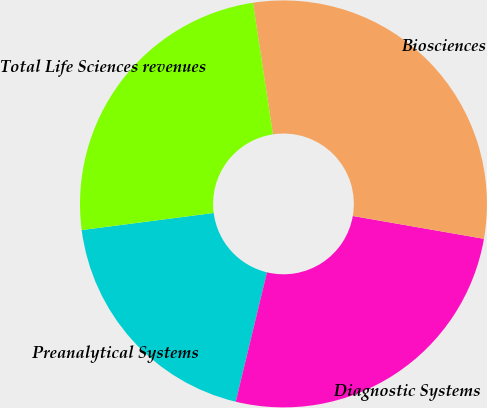Convert chart to OTSL. <chart><loc_0><loc_0><loc_500><loc_500><pie_chart><fcel>Preanalytical Systems<fcel>Diagnostic Systems<fcel>Biosciences<fcel>Total Life Sciences revenues<nl><fcel>19.18%<fcel>26.03%<fcel>30.14%<fcel>24.66%<nl></chart> 